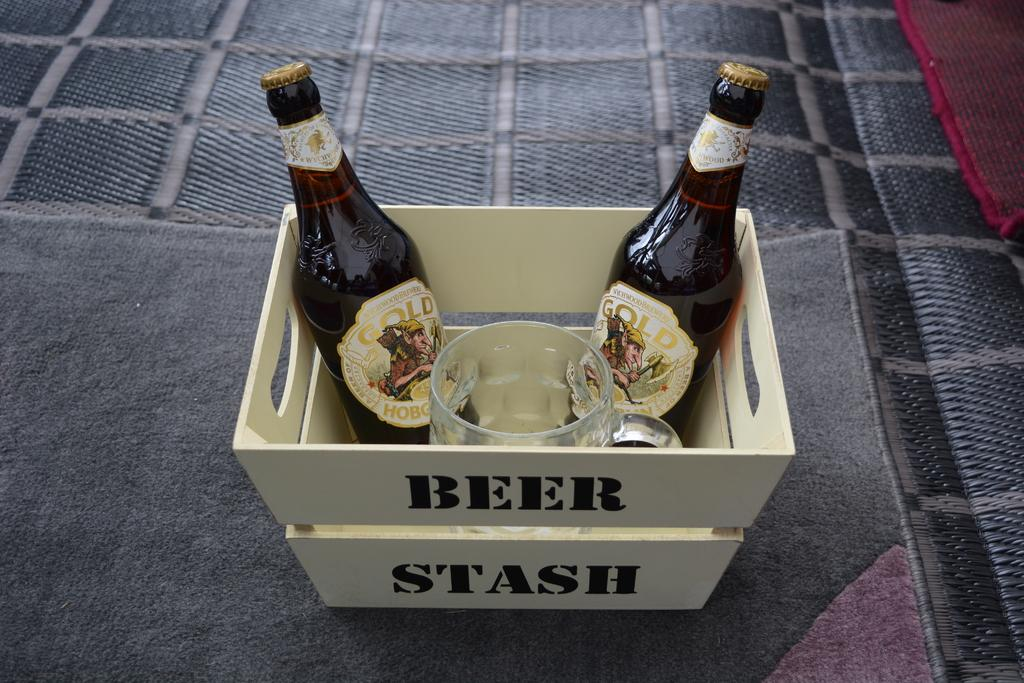Provide a one-sentence caption for the provided image. A crate labeled beer stash holds bottles and a glass mug. 